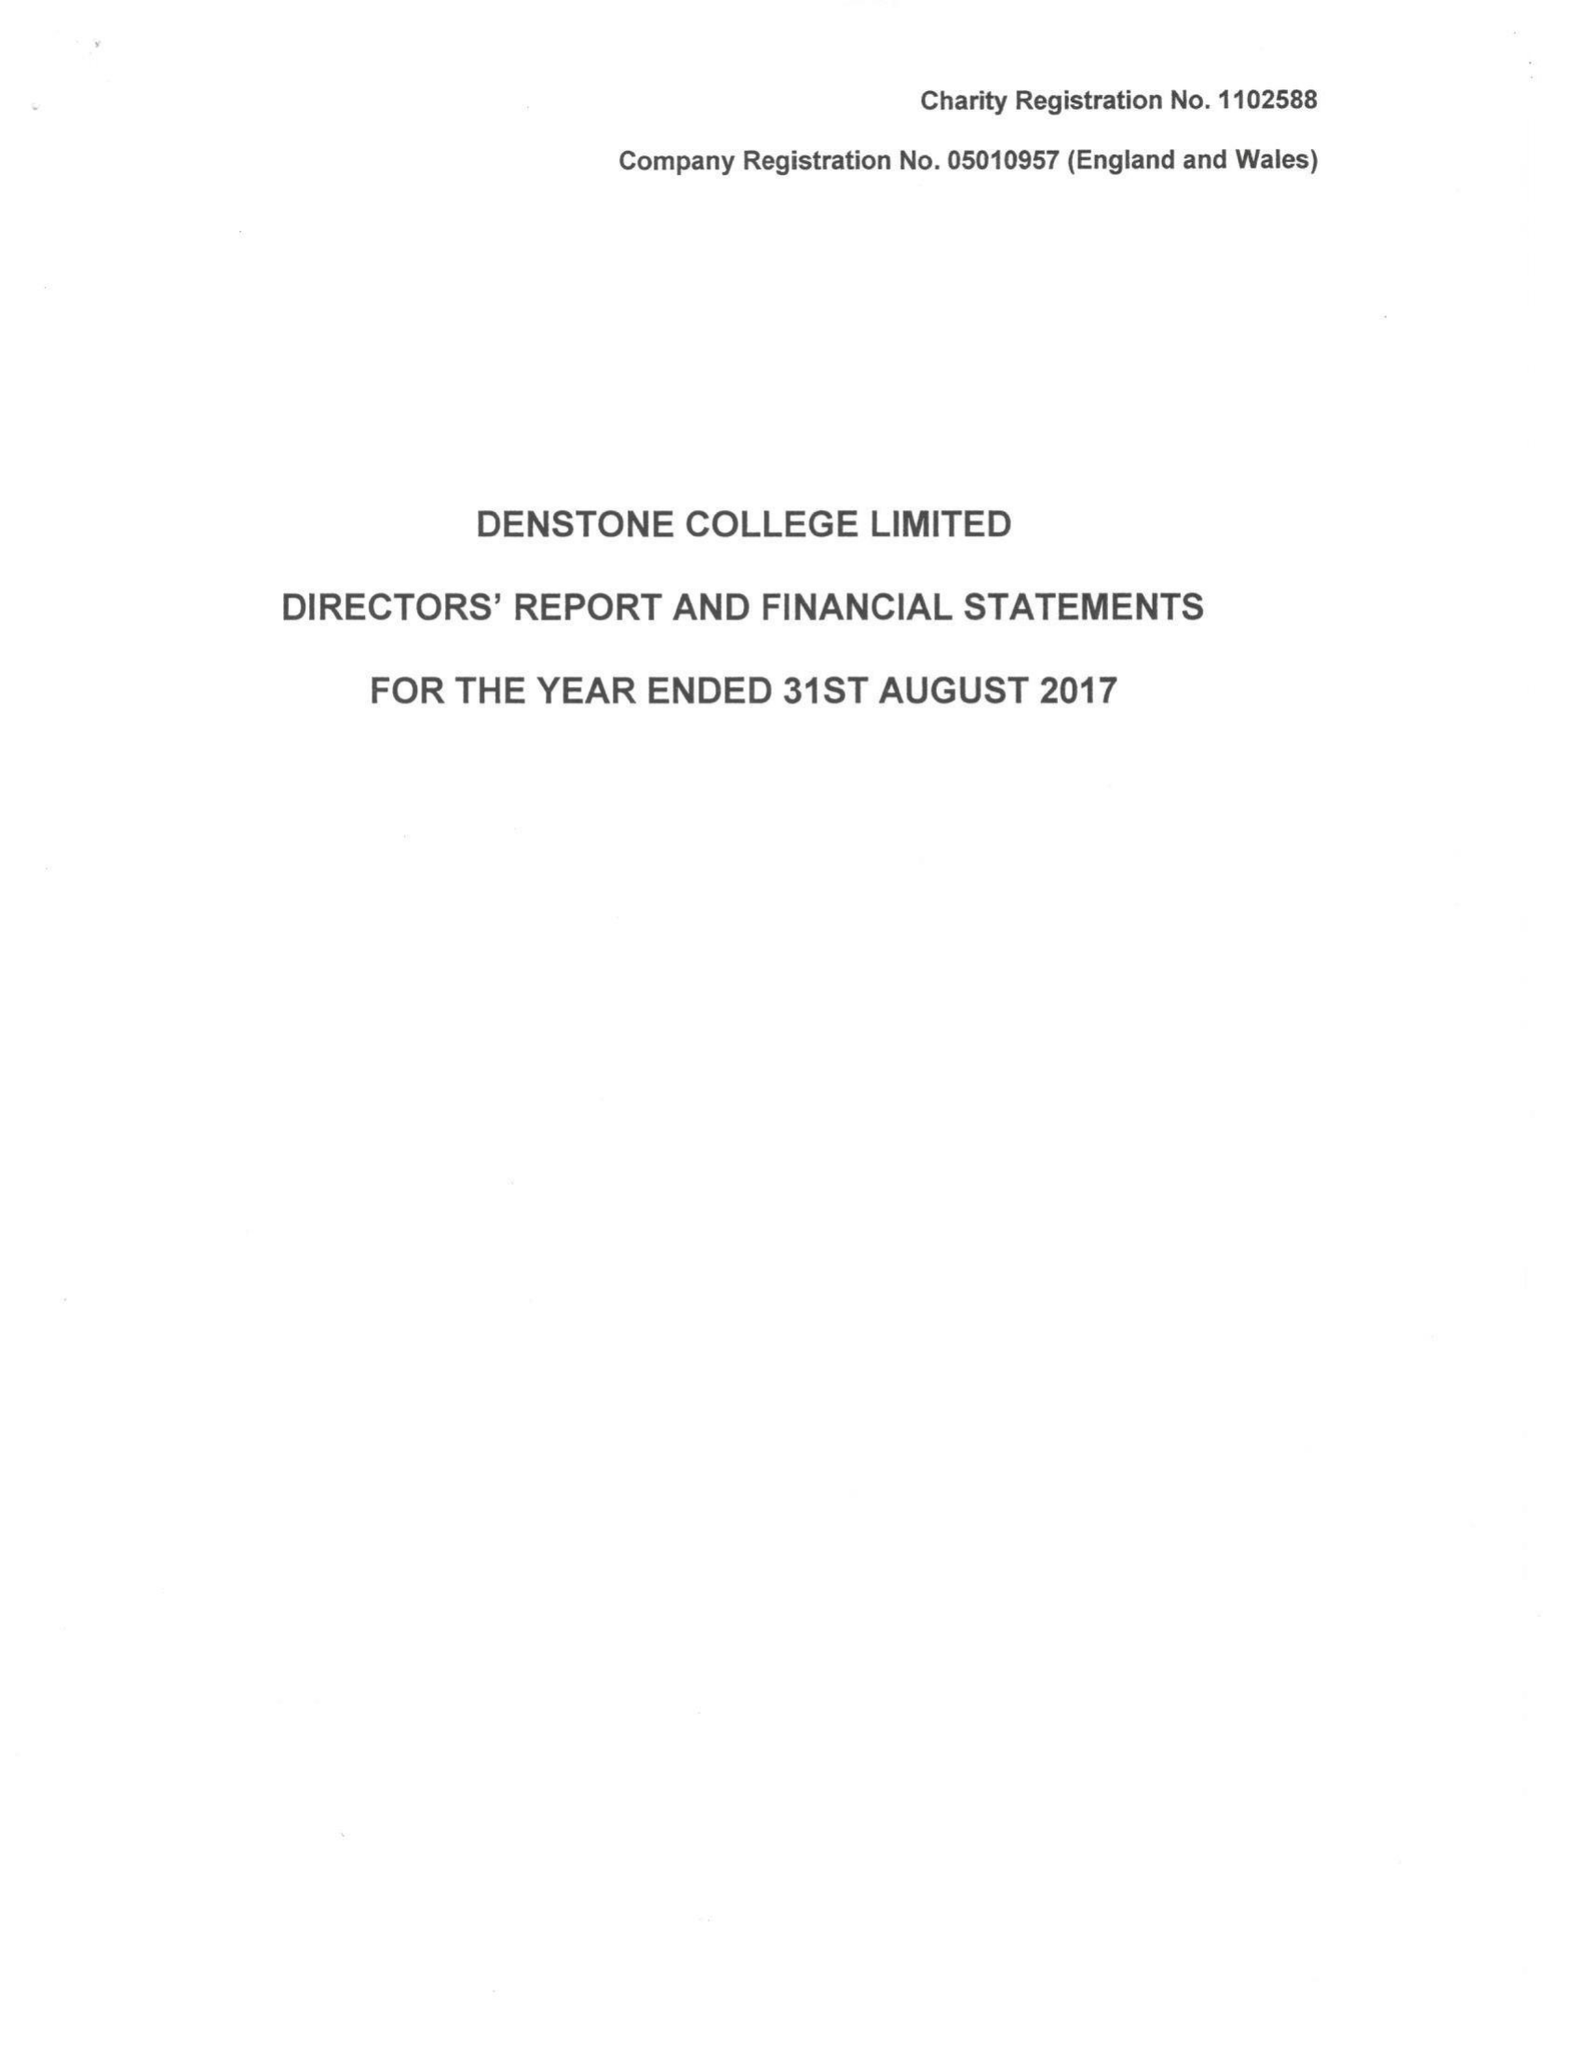What is the value for the income_annually_in_british_pounds?
Answer the question using a single word or phrase. 9736038.00 